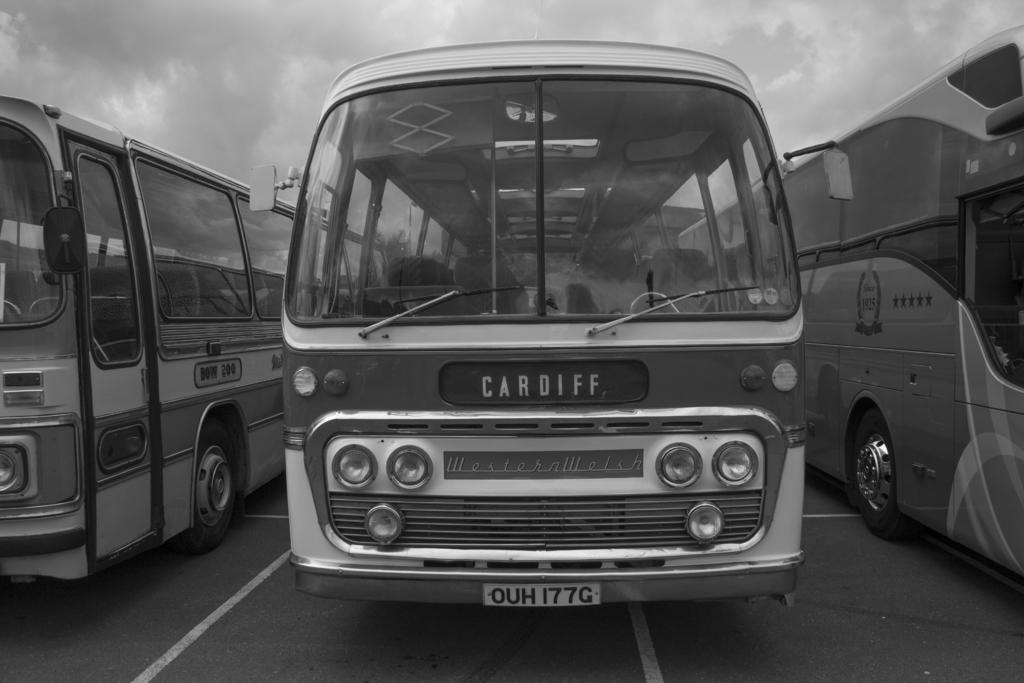<image>
Share a concise interpretation of the image provided. A black and white image of an old bus with cardiff set as its destination stands between two other busses. 